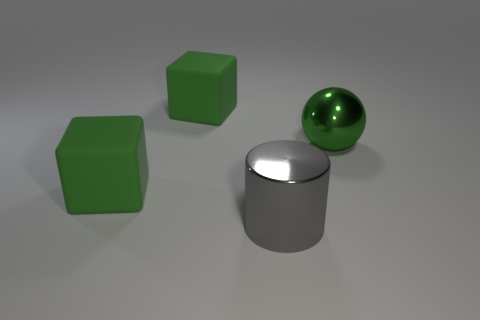There is a large ball that is the same material as the big gray cylinder; what is its color?
Your answer should be very brief. Green. Is the number of big shiny cylinders less than the number of big objects?
Give a very brief answer. Yes. What material is the big green block that is behind the big matte thing in front of the large object behind the metal ball?
Ensure brevity in your answer.  Rubber. What is the material of the large cylinder?
Provide a short and direct response. Metal. There is a metal thing behind the gray object; does it have the same color as the large rubber thing that is behind the green sphere?
Offer a very short reply. Yes. Are there more rubber cubes than green metal spheres?
Your response must be concise. Yes. How many large rubber cubes have the same color as the large sphere?
Keep it short and to the point. 2. What is the big thing that is to the left of the big gray metal cylinder and in front of the ball made of?
Your answer should be compact. Rubber. Is the block in front of the large green sphere made of the same material as the big thing that is behind the big ball?
Make the answer very short. Yes. The green metal object has what size?
Ensure brevity in your answer.  Large. 